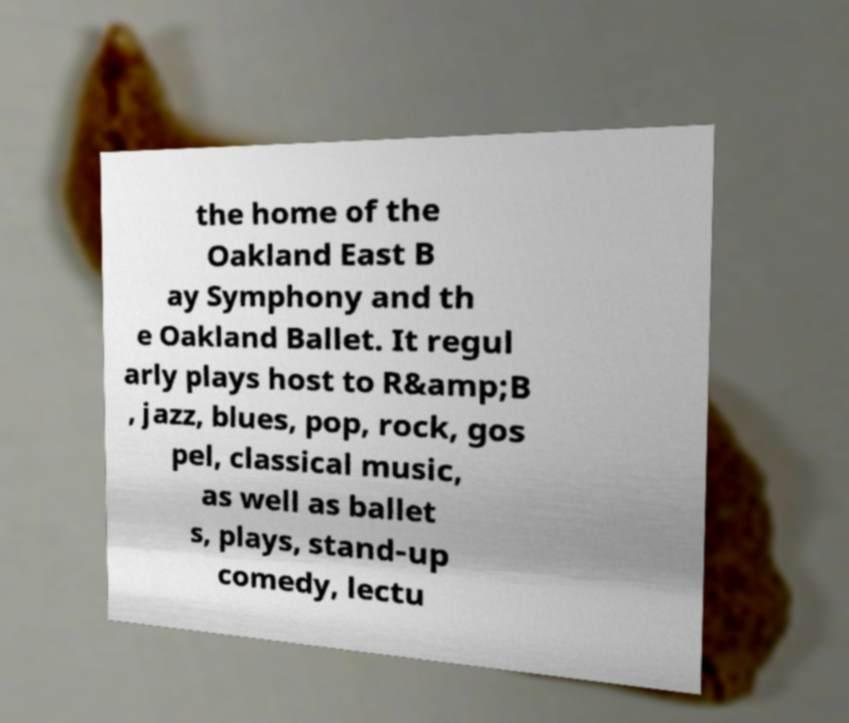Could you extract and type out the text from this image? the home of the Oakland East B ay Symphony and th e Oakland Ballet. It regul arly plays host to R&amp;B , jazz, blues, pop, rock, gos pel, classical music, as well as ballet s, plays, stand-up comedy, lectu 